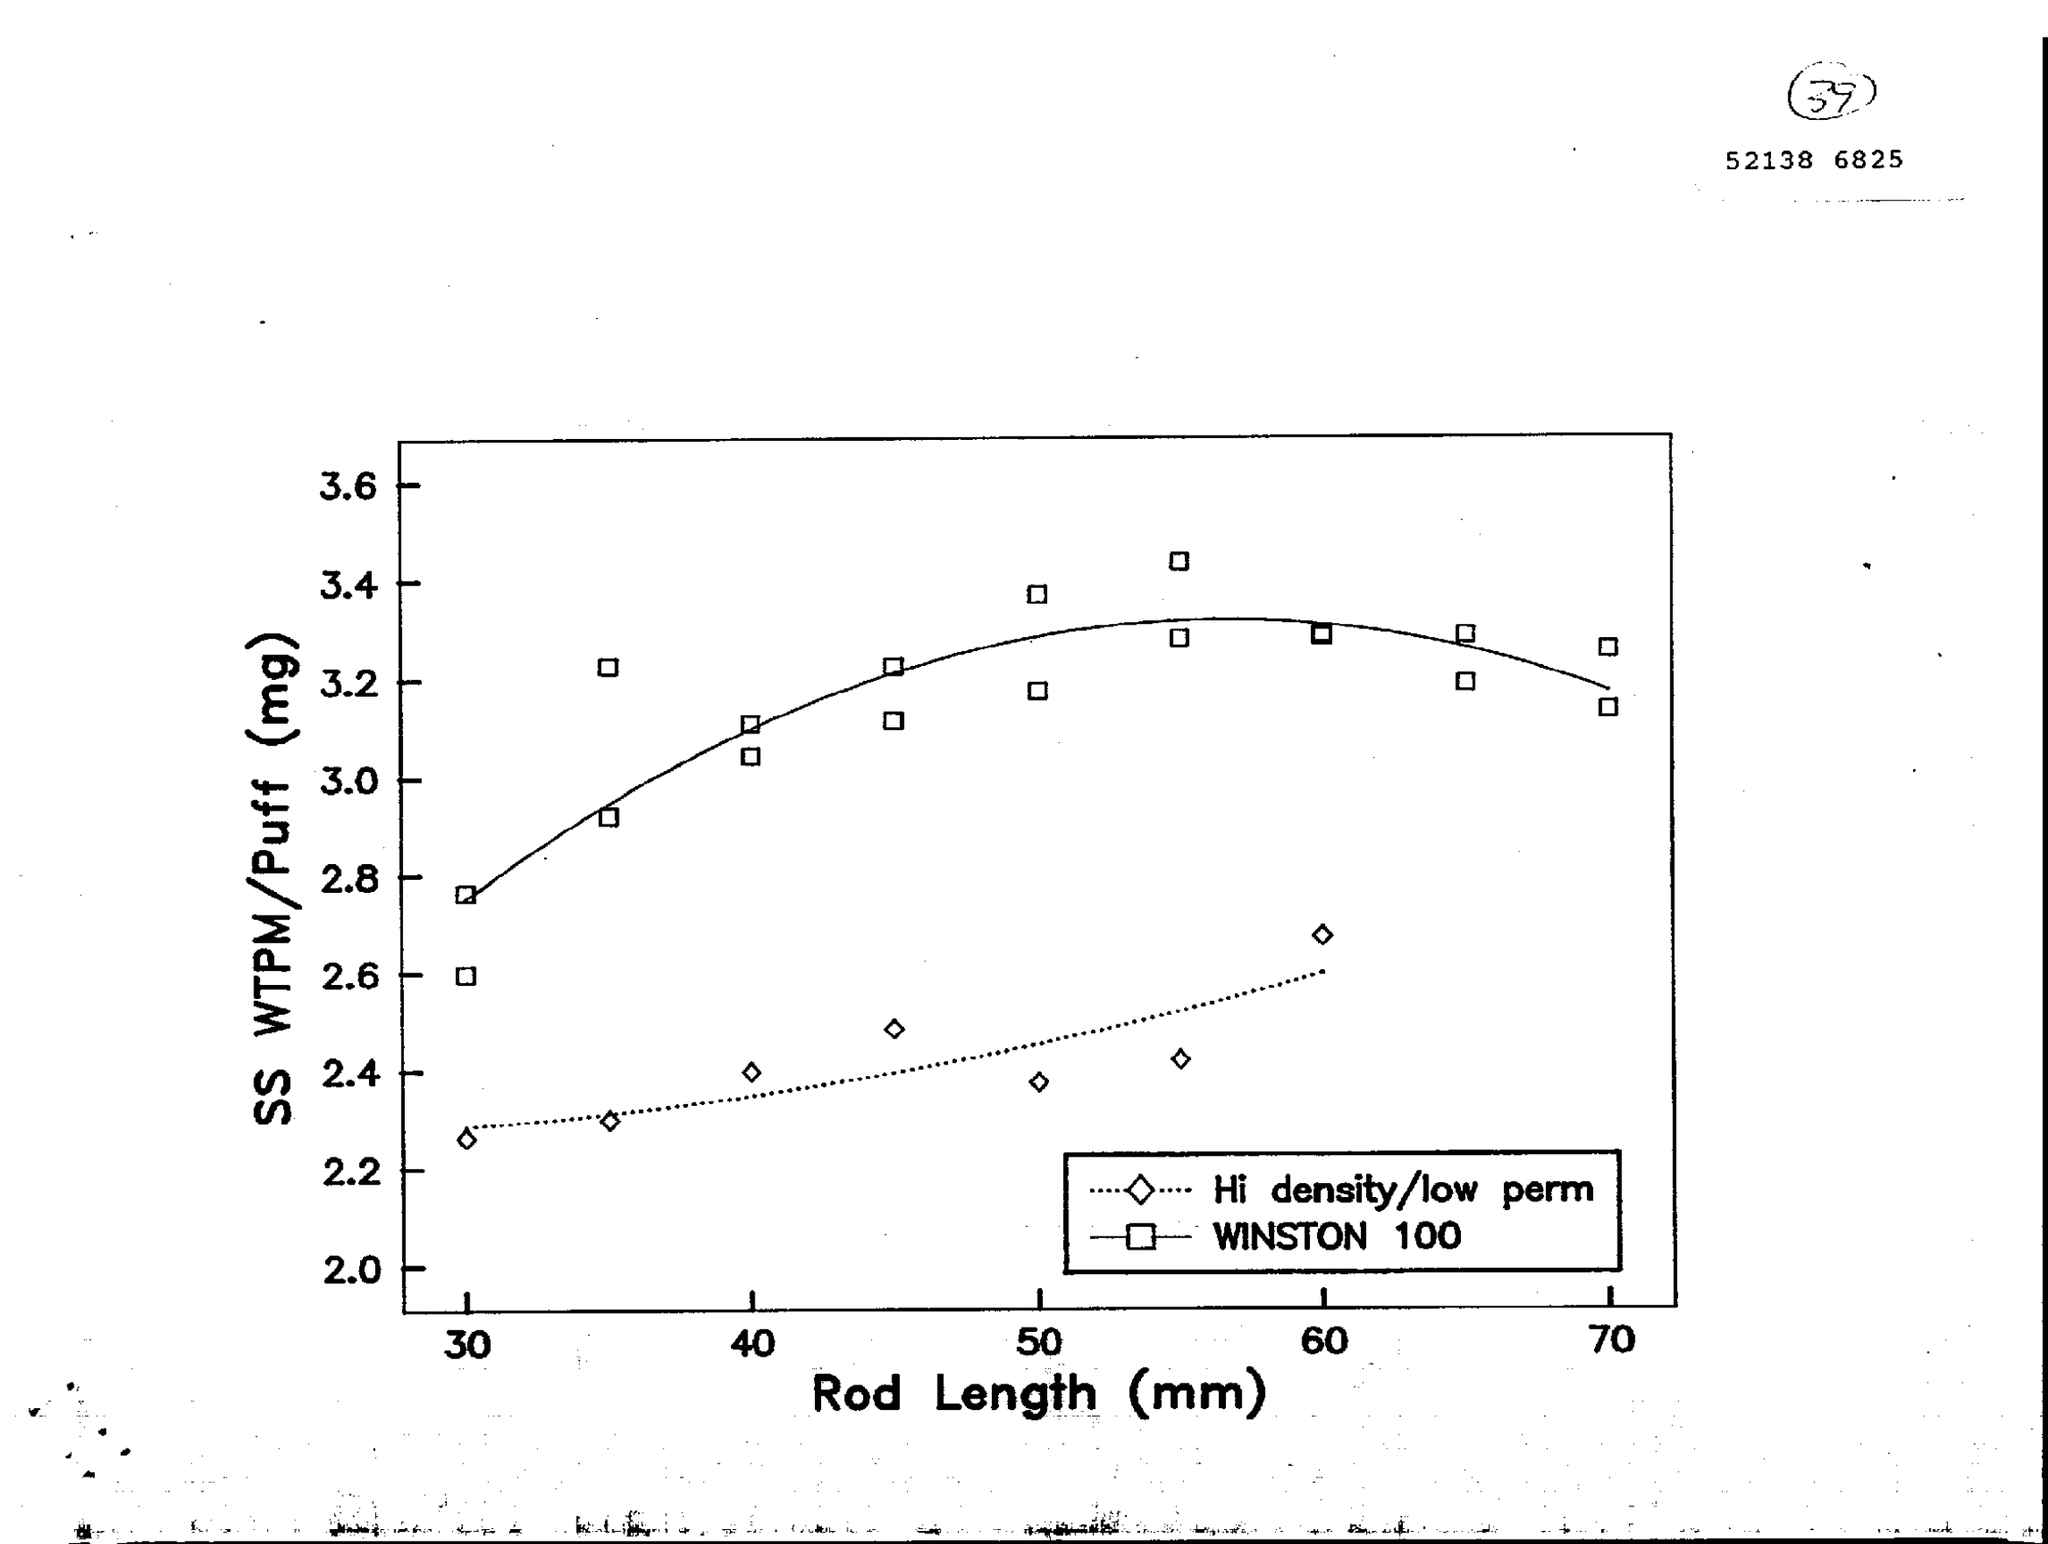Indicate a few pertinent items in this graphic. The variable on the x-axis of the graph is rod length in millimeters. The variable on the y-axis of the graph is the amount of SS WTPM/Puff (mg) consumed. 